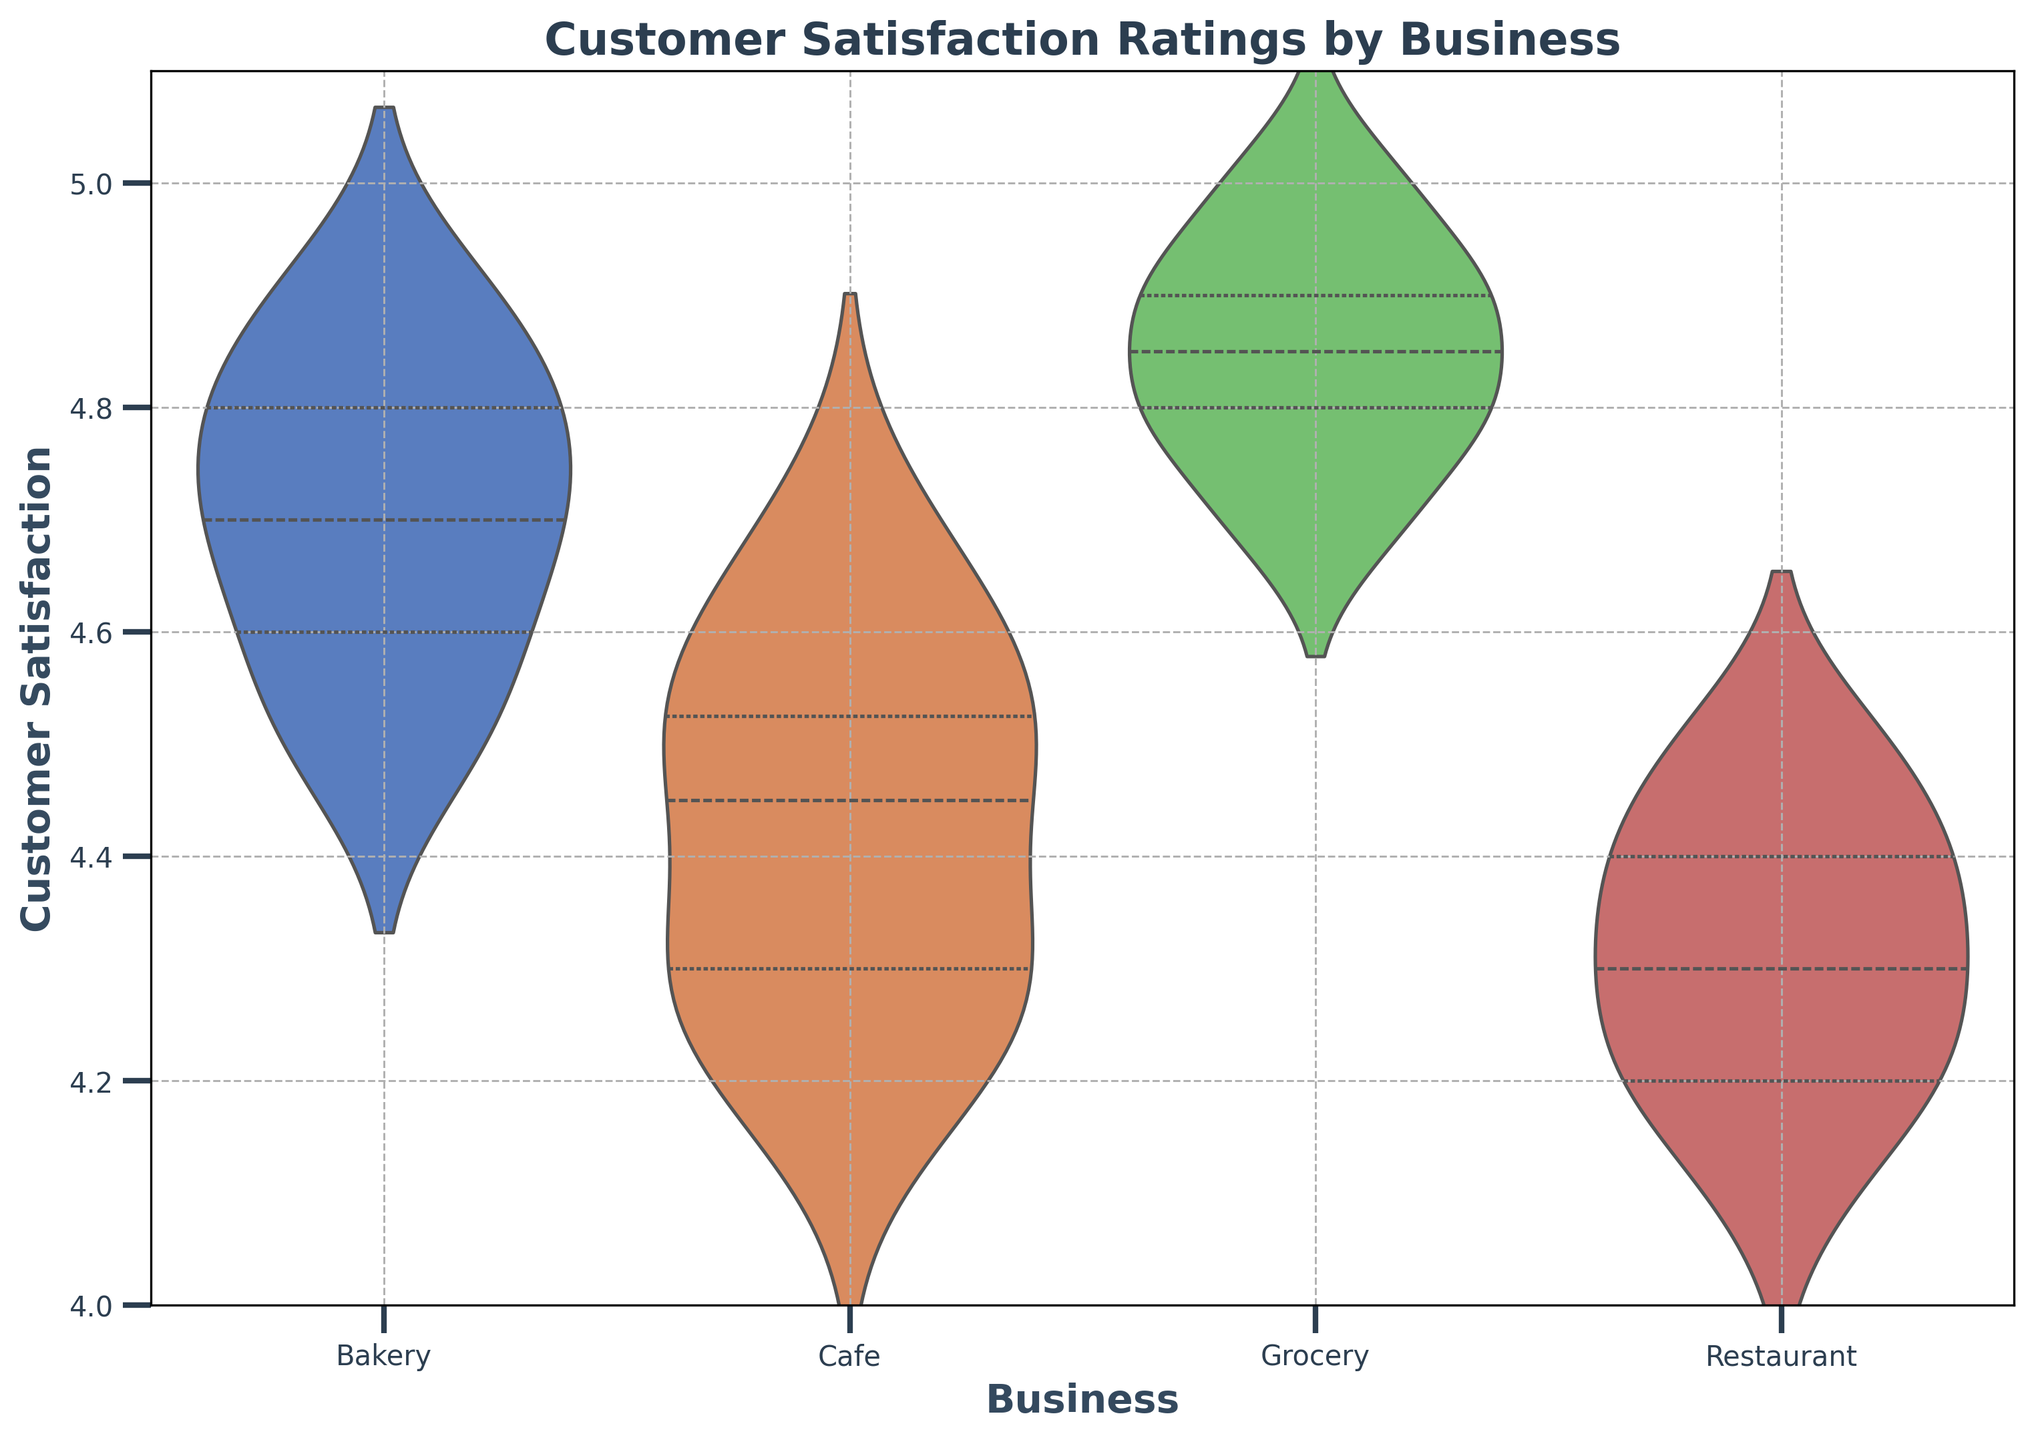What is the highest customer satisfaction rating given to the Grocery business? The top edge of the Grocery violin plot represents the highest customer satisfaction rating. The highest rating appears to reach 5.0.
Answer: 5.0 Which business shows the least variation in customer satisfaction ratings? The width of each violin plot indicates the distribution and spread of data points. The Bakery business has a relatively narrow violin plot, suggesting the least variation in customer satisfaction ratings.
Answer: Bakery How does the average customer satisfaction rating for the Cafe compare to the Bakery? The central line of the Cafe and Bakery violin plots represents the median satisfaction ratings. The average rating of the Cafe appears somewhat lower than the Bakery. Comparing the central lines shows that the Bakery’s average rating is higher.
Answer: Higher for Bakery What visual feature shows the range of customer satisfaction for the Restaurant? The height and shading of the Restaurant violin plot represent the range of customer satisfaction ratings. The highest and lowest points on the plot highlight the data spread from the minimum to the maximum ratings.
Answer: Height and shading Which two businesses have the most similar median customer satisfaction ratings based on the plot? The central white line within each violin plot denotes the median. The Cafe and Restaurant violin plots exhibit similar central lines, indicating comparable median ratings.
Answer: Cafe and Restaurant Is there any business with a customer satisfaction rating lower than 4.2? The lowest point of each violin plot denotes the minimum rating. For the data presented, the Restaurant and Cafe have the lowest ratings, touching 4.1.
Answer: Yes What’s the difference between the highest and lowest customer satisfaction ratings for the Restaurant business? The highest and lowest points of the Restaurant violin plot indicate the range. The highest point is 4.5 and the lowest is 4.1. The difference is 4.5 - 4.1.
Answer: 0.4 Does the Bakery or the Grocery business have a higher spread besides having the highest peak in customer satisfaction ratings? The grocery business displays the highest peak at 5.0, indicated by the upper part of the violin plot. The Bakery and Grocery exhibit wide dispersions, but the Grocery has a broader peak range.
Answer: Grocery How does the variability in customer satisfaction ratings compare between the Cafe and the Restaurant? The widths of the Cafe and Restaurant violin plots reflect the spread of ratings. The Cafe plot exhibits more variability as it is broader compared to the Restaurant plot with a more narrow spread.
Answer: Cafe 